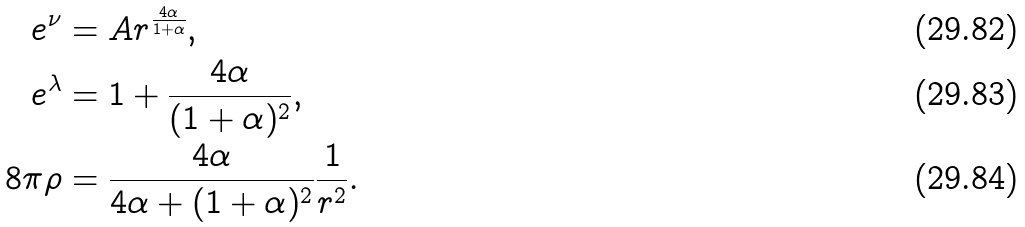<formula> <loc_0><loc_0><loc_500><loc_500>e ^ { \nu } & = A r ^ { \frac { 4 \alpha } { 1 + \alpha } } , \\ e ^ { \lambda } & = 1 + \frac { 4 \alpha } { ( 1 + \alpha ) ^ { 2 } } , \\ 8 \pi \rho & = \frac { 4 \alpha } { 4 \alpha + ( 1 + \alpha ) ^ { 2 } } \frac { 1 } { r ^ { 2 } } .</formula> 